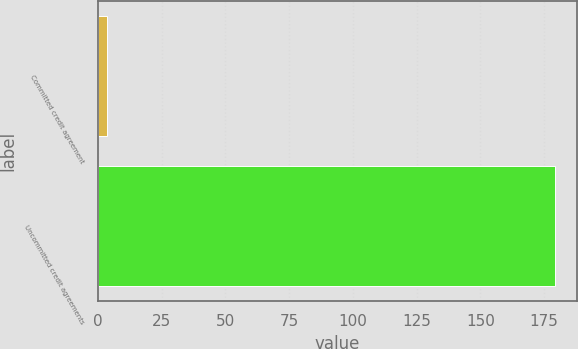Convert chart to OTSL. <chart><loc_0><loc_0><loc_500><loc_500><bar_chart><fcel>Committed credit agreement<fcel>Uncommitted credit agreements<nl><fcel>3.7<fcel>179.1<nl></chart> 